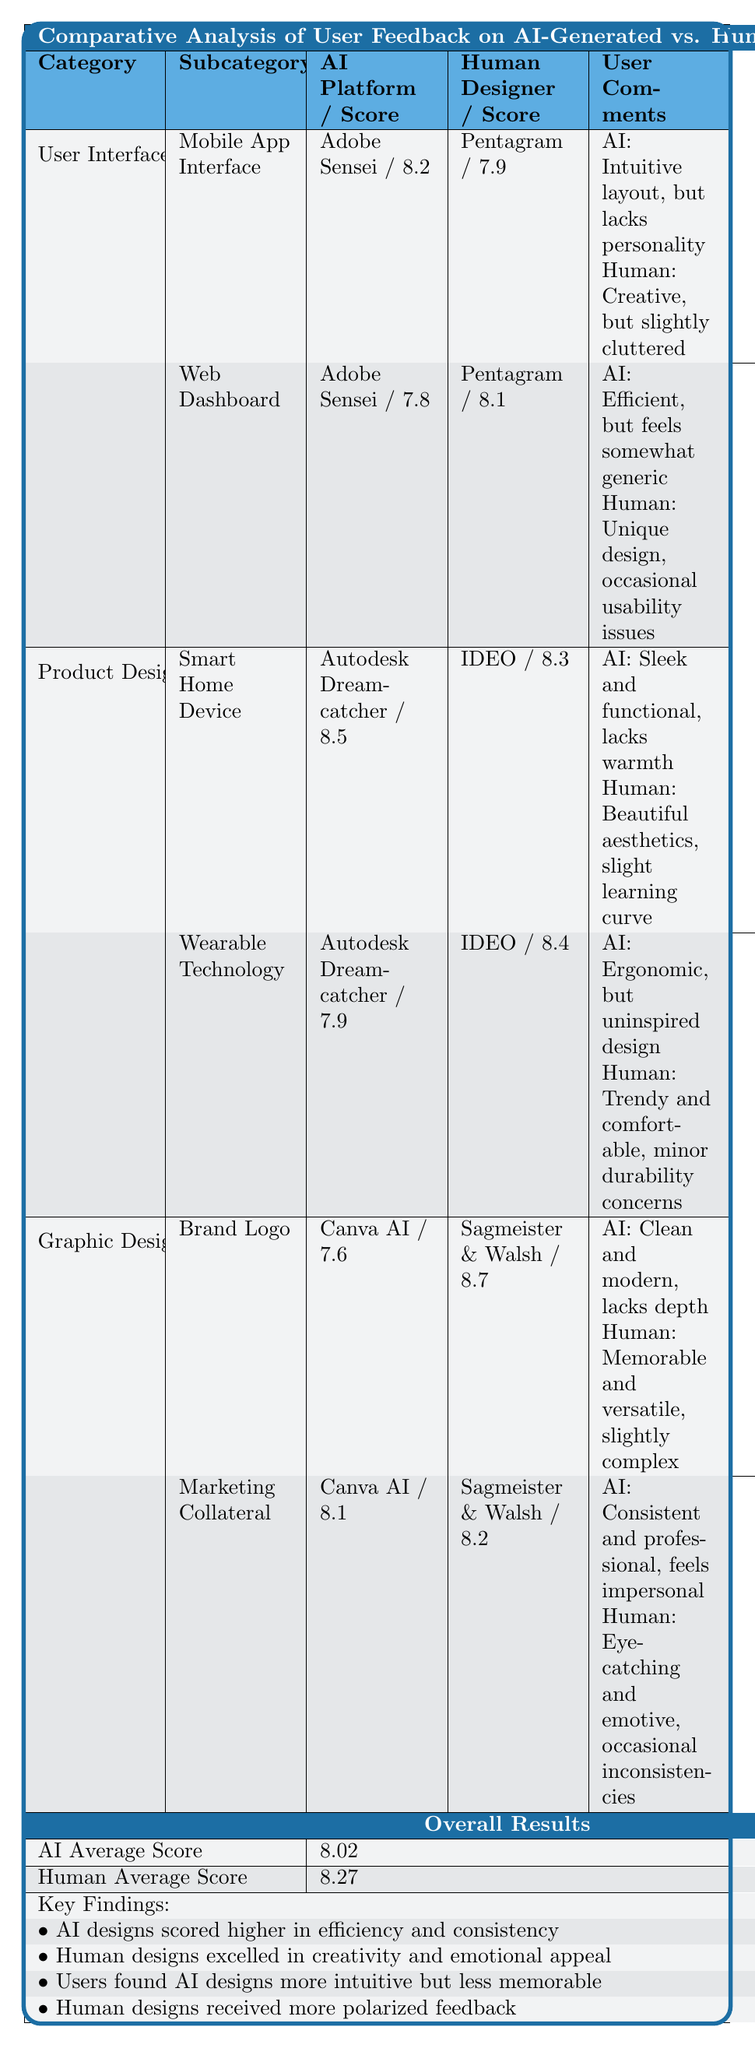What is the AI satisfaction score for the Smart Home Device? The table shows the AI satisfaction score for the Smart Home Device listed under Product Design, which is 8.5.
Answer: 8.5 What is the human satisfaction score for the Brand Logo? The table indicates the human satisfaction score for the Brand Logo under Graphic Design is 8.7.
Answer: 8.7 Which design category has the highest average satisfaction score between AI and Human? To find this, we examine the average scores for each design category in the table: User Interface Design's AI average is 8.0, Product Design's AI average is 8.2, and Graphic Design's AI average is 7.9. For Humans, the averages are 8.0 for User Interface, 8.35 for Product Design, and 8.55 for Graphic Design. The highest AI average is 8.5 for Product Design, and for Human is 8.7 for Graphic Design.
Answer: Brand Logo (Graphic Design) has the highest score (8.7) What is the difference between the AI and human average satisfaction scores? From the table, the AI average score is 8.02 and the human average score is 8.27. The difference is calculated as 8.27 - 8.02 = 0.25.
Answer: 0.25 Do users find AI designs more intuitive than human designs? According to the overall results in the table, users found AI designs more intuitive, as explicitly stated in the key findings.
Answer: Yes In which specific subcategory did AI score higher than human designs? By examining the subcategories, we see that for the Smart Home Device and Marketing Collateral, the AI scores (8.5 and 8.1) are higher than the human scores (8.3 and 8.2) respectively. The Smart Home Device under Product Design has the highest AI score compared to human scores.
Answer: Smart Home Device What percentage of feedback emphasized emotional appeal in human designs? While the table indicates that human designs excelled in creativity and emotional appeal, it does not provide a specific percentage of feedback related to emotional appeal. Thus, there is no calculable percentage available from the table.
Answer: Not specify Which user interface design received the highest satisfaction score overall? The table shows that the Mobile App Interface under User Interface Design has an AI satisfaction score of 8.2 and a human satisfaction score of 7.9. Comparatively, it has the highest AI satisfaction in the User Interface category, while the Web Dashboard scored lower for AI (7.8), making Mobile App Interface the highest overall score in user feedback.
Answer: Mobile App Interface What are the key findings regarding the emotional aspects of human vs. AI designs? From the table's key findings, it is noted that human designs excelled in emotional appeal while AI designs scored higher in efficiency and consistency. This suggests a clear distinction where human-created designs resonate more emotionally with users.
Answer: Human designs excel in emotional appeal 